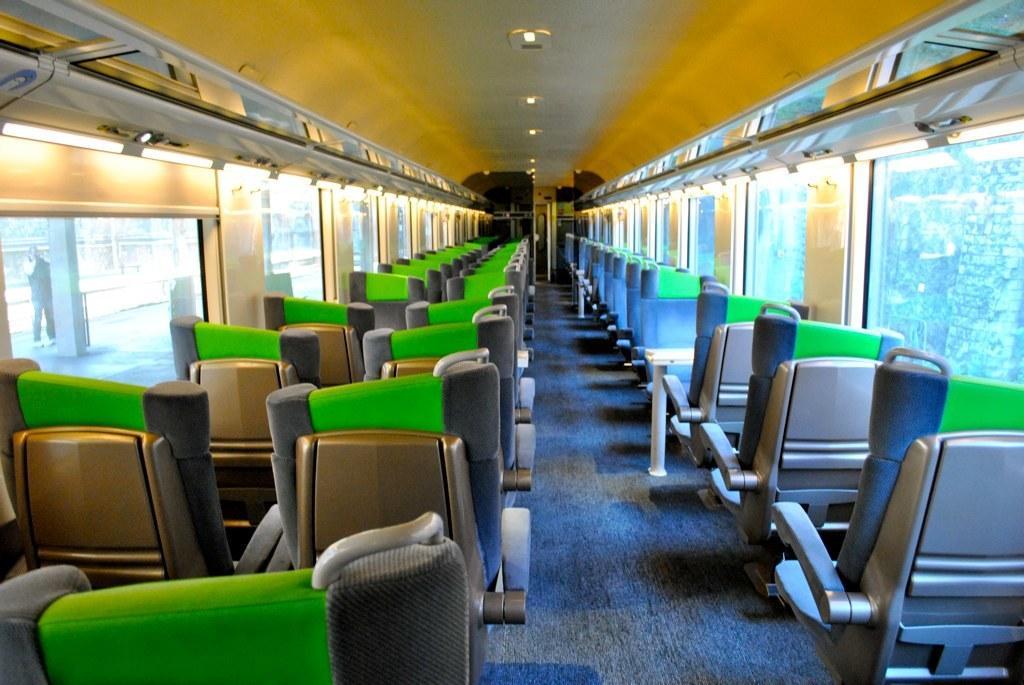How would you summarize this image in a sentence or two? In this image we can see some seats of a locomotive and this is the inside view of a locomotive, there are some glasses on left and right side of the image and top of the image there are lights. 